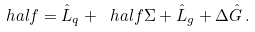Convert formula to latex. <formula><loc_0><loc_0><loc_500><loc_500>\ h a l f = \hat { L } _ { q } + \ h a l f \Sigma + \hat { L } _ { g } + \Delta \hat { G } \, .</formula> 